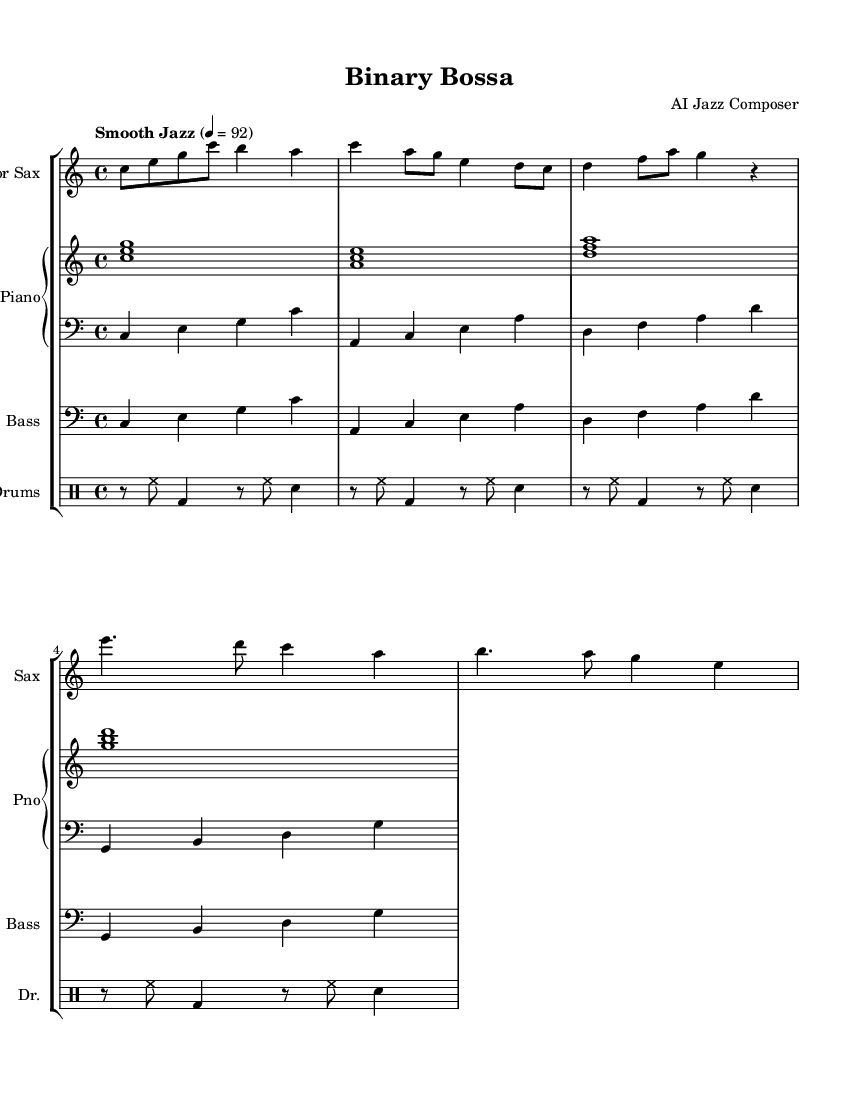What is the key signature of this music? The key signature is C major, which has no sharps or flats as indicated by the absence of accidentals.
Answer: C major What is the time signature of this music? The time signature is found at the beginning, which shows there are four beats in each measure. This is indicated by the "4/4" symbol.
Answer: 4/4 What instruments are involved in this piece? The instruments are identified at the start of each staff, showing a tenor saxophone, piano (with right and left hand staves), bass, and drums.
Answer: Tenor Saxophone, Piano, Bass, Drums What tempo marking is given for this piece? The tempo marking is specified as "Smooth Jazz" with a metronome marking of quarter note equals 92, indicating a laid-back feel typical of smooth jazz.
Answer: Smooth Jazz, 92 How many measures are present in the main theme (A)? The main theme is represented in the music and can be counted from the notation, which contains four measures. Each measure is separated by a vertical line.
Answer: 4 What characteristic of jazz can be observed in the drum pattern? The drum pattern shows syncopation, which is a key characteristic of jazz, providing a groove that's not strictly on the beat but rather off-beat accents.
Answer: Syncopation How does the bass line contribute to the smooth jazz style? The bass line uses repetition and steady quarter notes, creating a consistent groundwork that supports the improvisational feel often found in jazz pieces.
Answer: Repetition and steady quarter notes 